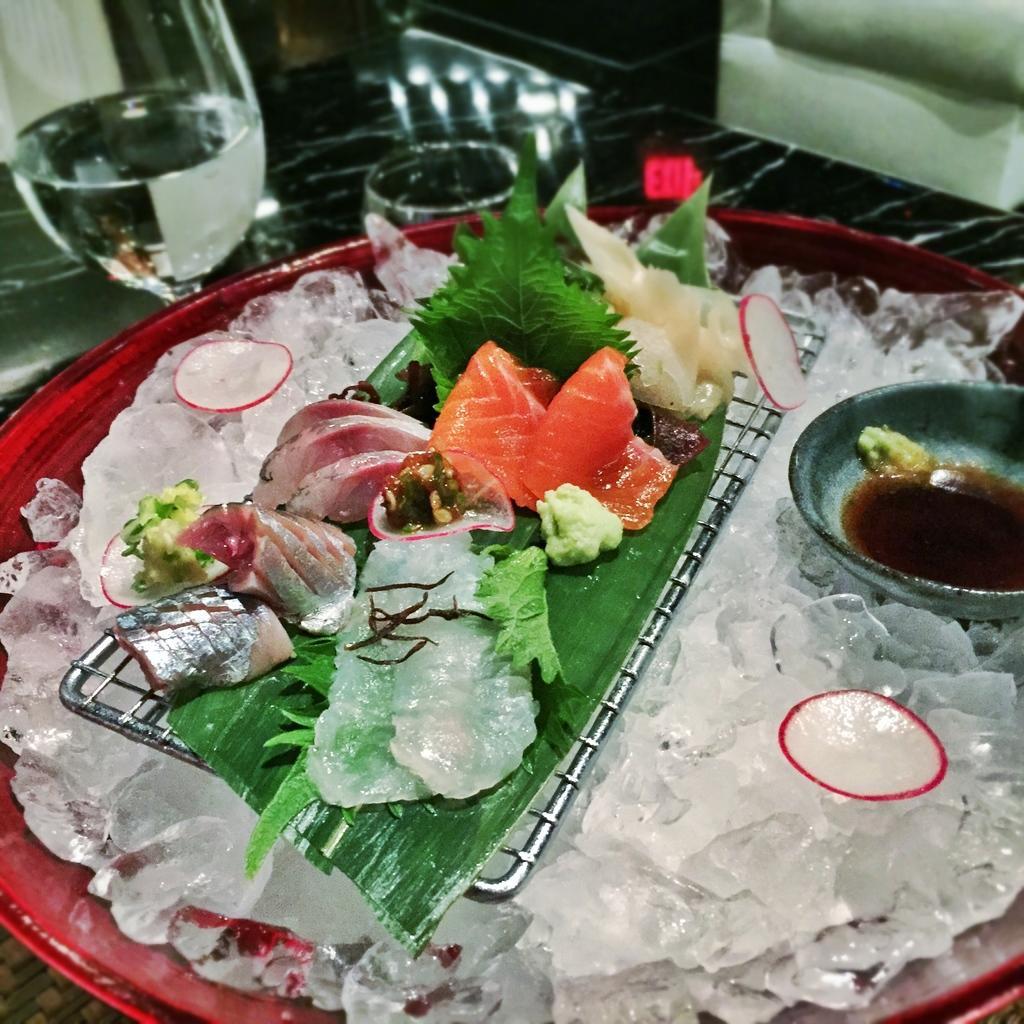Describe this image in one or two sentences. In this image there is a plate having ice cubes. On it there is a girl having a leaf. There is some food kept on the leaf. Right side there is a bowl kept on the ice cubes. Bowl is having some food. Left top glasses and few objects are kept on the table. 